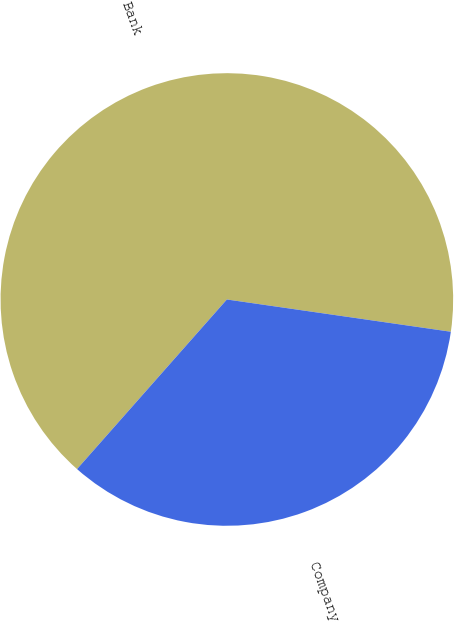Convert chart to OTSL. <chart><loc_0><loc_0><loc_500><loc_500><pie_chart><fcel>Bank<fcel>Company<nl><fcel>65.76%<fcel>34.24%<nl></chart> 